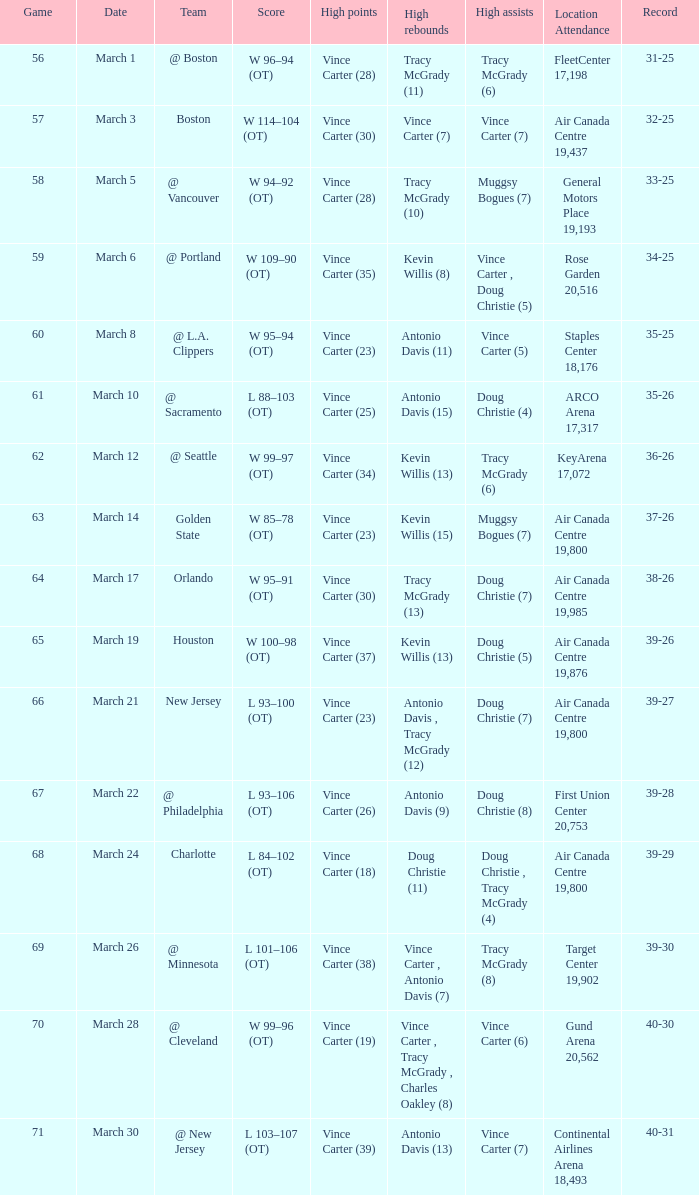Could you help me parse every detail presented in this table? {'header': ['Game', 'Date', 'Team', 'Score', 'High points', 'High rebounds', 'High assists', 'Location Attendance', 'Record'], 'rows': [['56', 'March 1', '@ Boston', 'W 96–94 (OT)', 'Vince Carter (28)', 'Tracy McGrady (11)', 'Tracy McGrady (6)', 'FleetCenter 17,198', '31-25'], ['57', 'March 3', 'Boston', 'W 114–104 (OT)', 'Vince Carter (30)', 'Vince Carter (7)', 'Vince Carter (7)', 'Air Canada Centre 19,437', '32-25'], ['58', 'March 5', '@ Vancouver', 'W 94–92 (OT)', 'Vince Carter (28)', 'Tracy McGrady (10)', 'Muggsy Bogues (7)', 'General Motors Place 19,193', '33-25'], ['59', 'March 6', '@ Portland', 'W 109–90 (OT)', 'Vince Carter (35)', 'Kevin Willis (8)', 'Vince Carter , Doug Christie (5)', 'Rose Garden 20,516', '34-25'], ['60', 'March 8', '@ L.A. Clippers', 'W 95–94 (OT)', 'Vince Carter (23)', 'Antonio Davis (11)', 'Vince Carter (5)', 'Staples Center 18,176', '35-25'], ['61', 'March 10', '@ Sacramento', 'L 88–103 (OT)', 'Vince Carter (25)', 'Antonio Davis (15)', 'Doug Christie (4)', 'ARCO Arena 17,317', '35-26'], ['62', 'March 12', '@ Seattle', 'W 99–97 (OT)', 'Vince Carter (34)', 'Kevin Willis (13)', 'Tracy McGrady (6)', 'KeyArena 17,072', '36-26'], ['63', 'March 14', 'Golden State', 'W 85–78 (OT)', 'Vince Carter (23)', 'Kevin Willis (15)', 'Muggsy Bogues (7)', 'Air Canada Centre 19,800', '37-26'], ['64', 'March 17', 'Orlando', 'W 95–91 (OT)', 'Vince Carter (30)', 'Tracy McGrady (13)', 'Doug Christie (7)', 'Air Canada Centre 19,985', '38-26'], ['65', 'March 19', 'Houston', 'W 100–98 (OT)', 'Vince Carter (37)', 'Kevin Willis (13)', 'Doug Christie (5)', 'Air Canada Centre 19,876', '39-26'], ['66', 'March 21', 'New Jersey', 'L 93–100 (OT)', 'Vince Carter (23)', 'Antonio Davis , Tracy McGrady (12)', 'Doug Christie (7)', 'Air Canada Centre 19,800', '39-27'], ['67', 'March 22', '@ Philadelphia', 'L 93–106 (OT)', 'Vince Carter (26)', 'Antonio Davis (9)', 'Doug Christie (8)', 'First Union Center 20,753', '39-28'], ['68', 'March 24', 'Charlotte', 'L 84–102 (OT)', 'Vince Carter (18)', 'Doug Christie (11)', 'Doug Christie , Tracy McGrady (4)', 'Air Canada Centre 19,800', '39-29'], ['69', 'March 26', '@ Minnesota', 'L 101–106 (OT)', 'Vince Carter (38)', 'Vince Carter , Antonio Davis (7)', 'Tracy McGrady (8)', 'Target Center 19,902', '39-30'], ['70', 'March 28', '@ Cleveland', 'W 99–96 (OT)', 'Vince Carter (19)', 'Vince Carter , Tracy McGrady , Charles Oakley (8)', 'Vince Carter (6)', 'Gund Arena 20,562', '40-30'], ['71', 'March 30', '@ New Jersey', 'L 103–107 (OT)', 'Vince Carter (39)', 'Antonio Davis (13)', 'Vince Carter (7)', 'Continental Airlines Arena 18,493', '40-31']]} What day was the attendance at the staples center 18,176? March 8. 